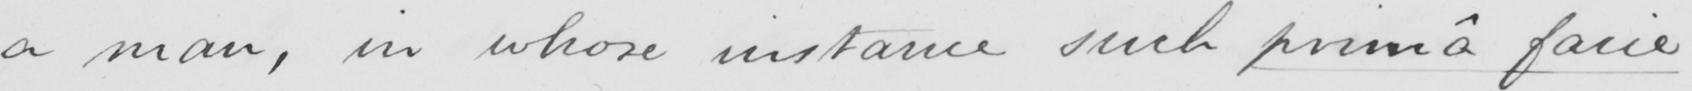Can you read and transcribe this handwriting? a man , in whose instance such primâ facie 